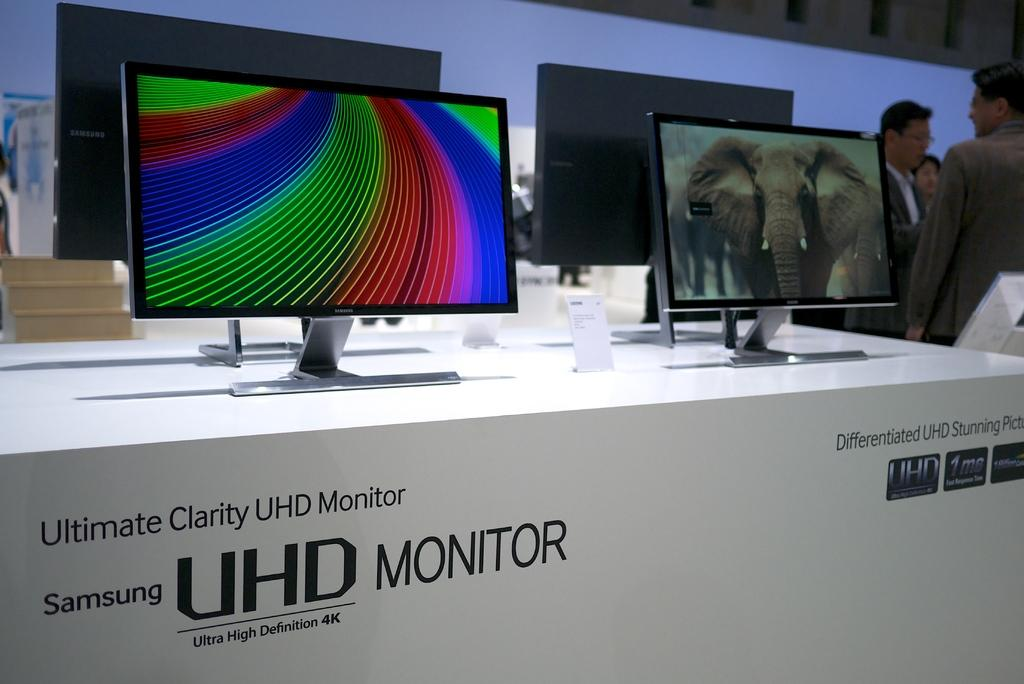<image>
Share a concise interpretation of the image provided. A store display features Samsung UHD monitors which offer a 4K picture. 